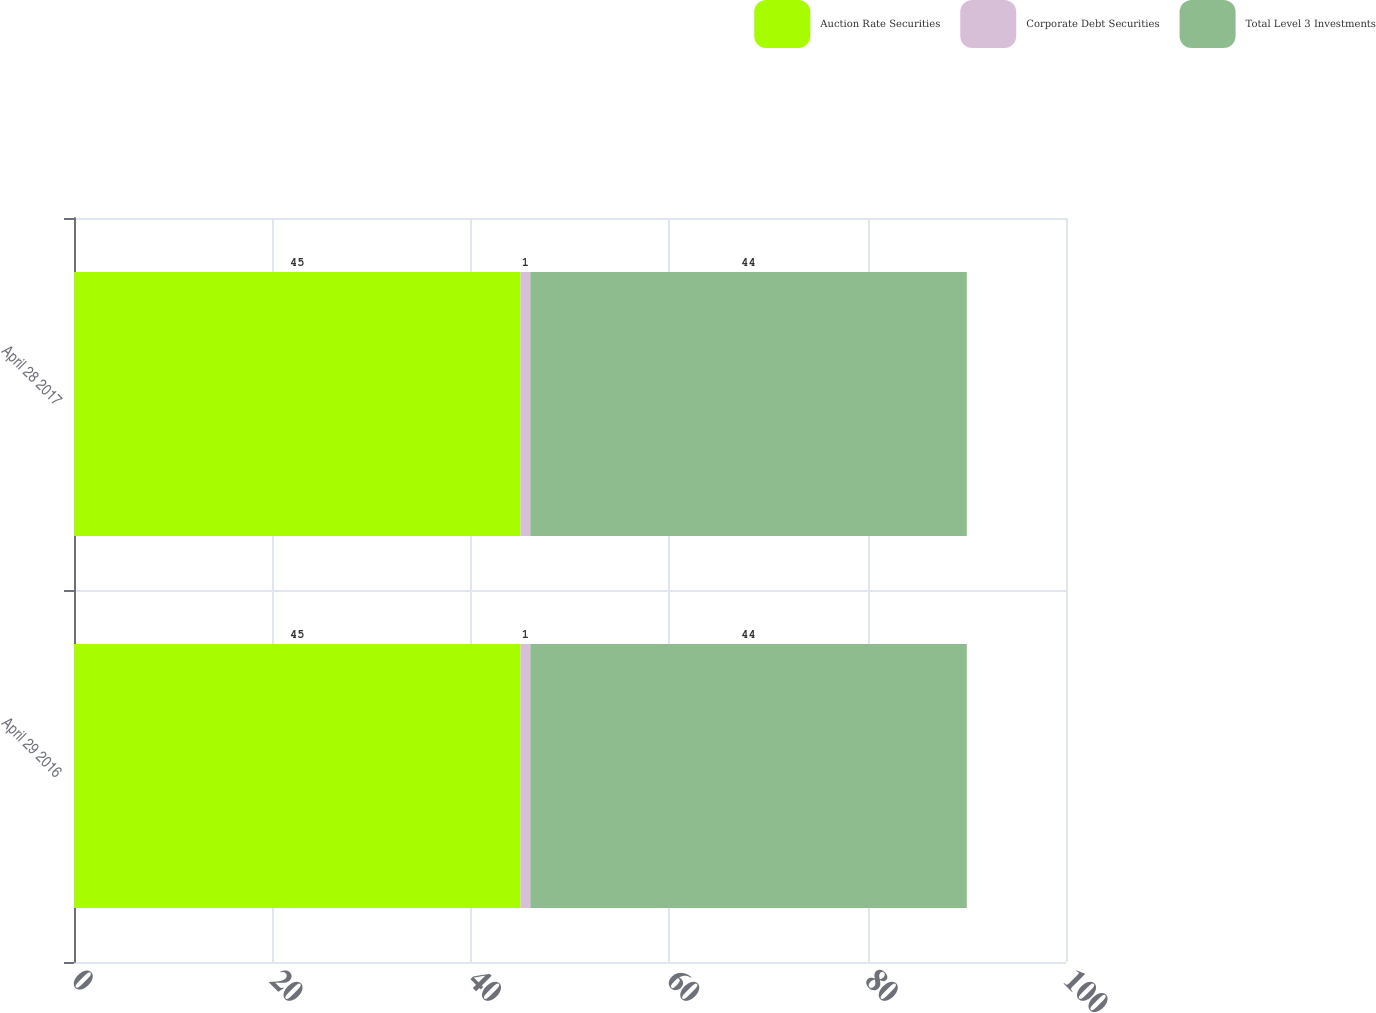<chart> <loc_0><loc_0><loc_500><loc_500><stacked_bar_chart><ecel><fcel>April 29 2016<fcel>April 28 2017<nl><fcel>Auction Rate Securities<fcel>45<fcel>45<nl><fcel>Corporate Debt Securities<fcel>1<fcel>1<nl><fcel>Total Level 3 Investments<fcel>44<fcel>44<nl></chart> 